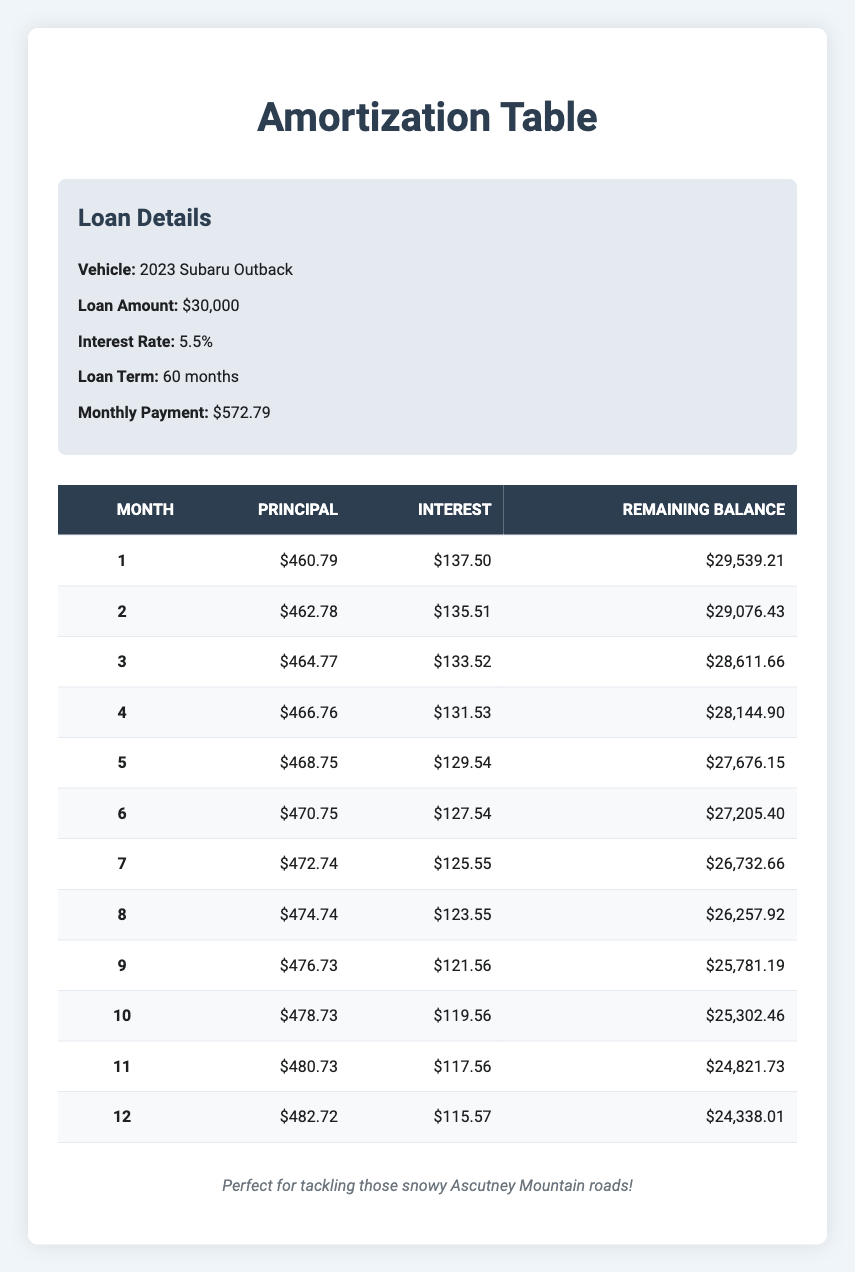What is the monthly payment for the loan? The monthly payment amount is presented in the loan details section of the table, where it states that the monthly payment is $572.79.
Answer: 572.79 What is the total amount paid toward the principal in the first month? The principal payment for the first month is listed in the payment breakdown table; it shows a value of $460.79.
Answer: 460.79 How much interest was paid in the third month? Referring to the payment breakdown, the interest payment for the third month is specifically stated as $133.52.
Answer: 133.52 How much does the remaining balance decrease from month 1 to month 2? To find the decrease in remaining balance, we subtract the remaining balance of month 2 ($29,076.43) from month 1 ($29,539.21): $29,539.21 - $29,076.43 = $462.78.
Answer: 462.78 Is the interest payment in month 12 less than in month 1? Comparing the interest payments for both months shows that month 12 has an interest payment of $115.57, while month 1 has an interest payment of $137.50. Since $115.57 is indeed less than $137.50, the answer is yes.
Answer: Yes What is the average principal payment over the first six months? We sum the principal payments of the first six months: 460.79 + 462.78 + 464.77 + 466.76 + 468.75 + 470.75 = 2,395.60. We then divide this total by 6, which gives us an average of approximately 399.27.
Answer: 399.27 What is the total interest paid in the first year? To calculate the total interest for the first year, we sum the interest payments for all 12 months: 137.50 + 135.51 + 133.52 + 131.53 + 129.54 + 127.54 + 125.55 + 123.55 + 121.56 + 119.56 + 117.56 + 115.57 = 1,639.07.
Answer: 1,639.07 How much is the remaining balance after the sixth month? The remaining balance after the sixth month is specifically listed in the payment breakdown table as $27,205.40.
Answer: 27,205.40 Did the principal payment increase every month for the first six months? By observing the principal payments for each of the first six months, we find that the amounts are: $460.79, $462.78, $464.77, $466.76, $468.75, and $470.75. All values show a consistent increase; thus, the answer is yes.
Answer: Yes 